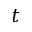Convert formula to latex. <formula><loc_0><loc_0><loc_500><loc_500>t</formula> 